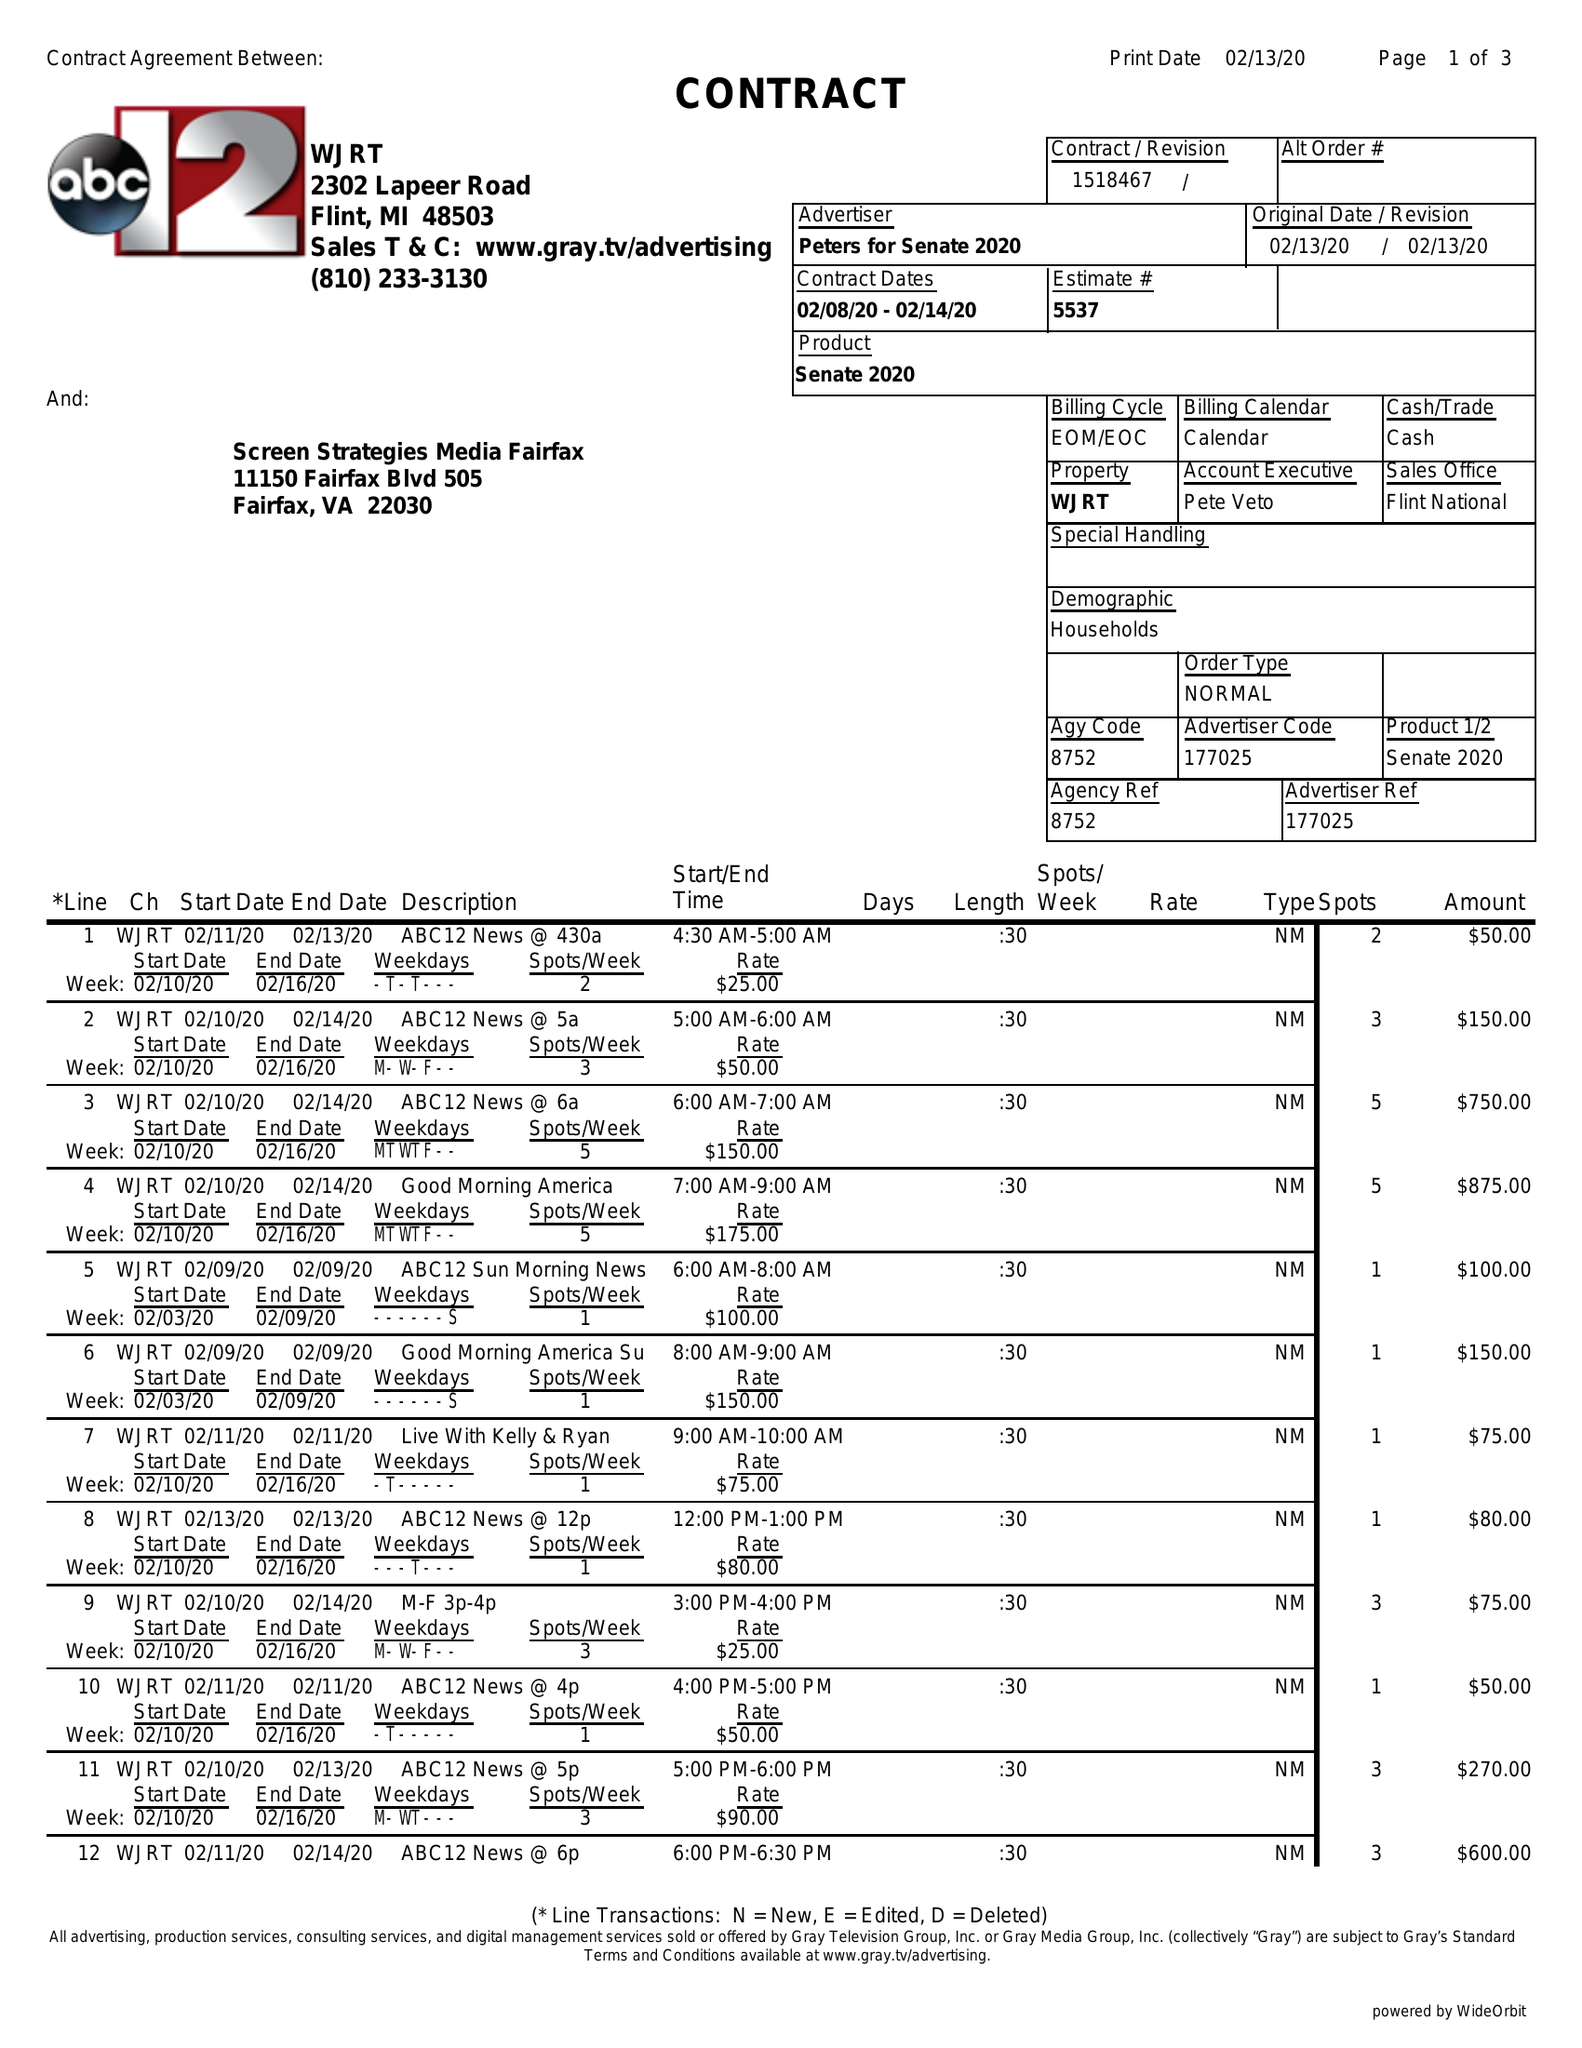What is the value for the gross_amount?
Answer the question using a single word or phrase. 6365.00 